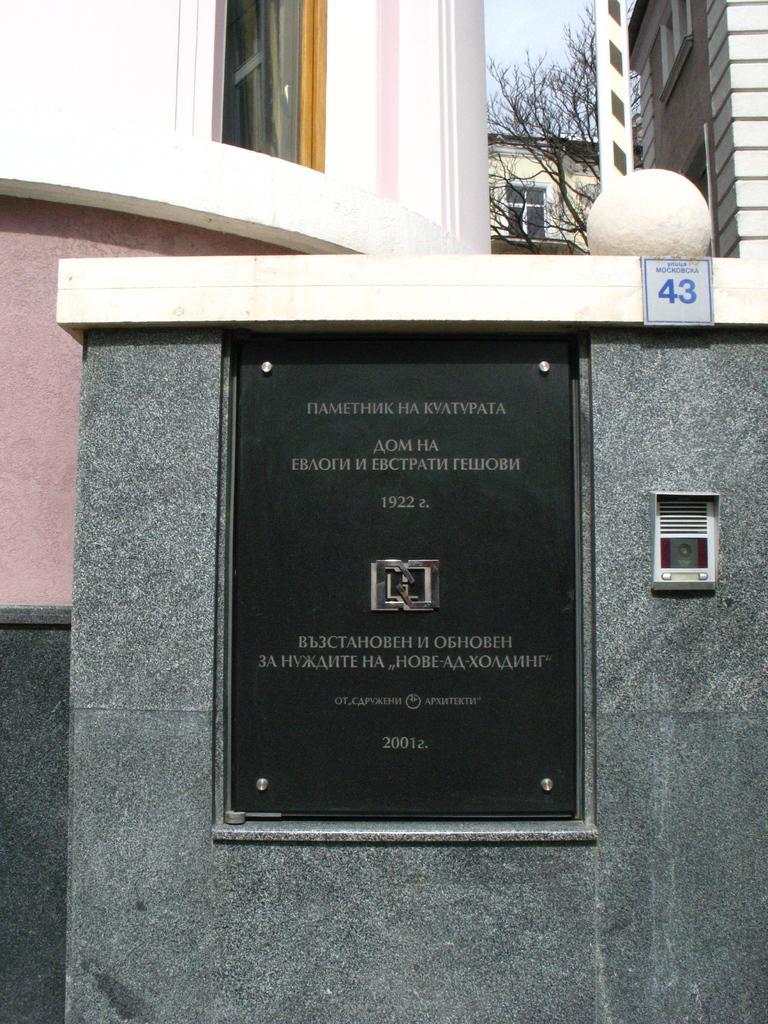Could you give a brief overview of what you see in this image? In this image I can see the black color board to the wall. In the background I can see the buildings, trees and the sky. 